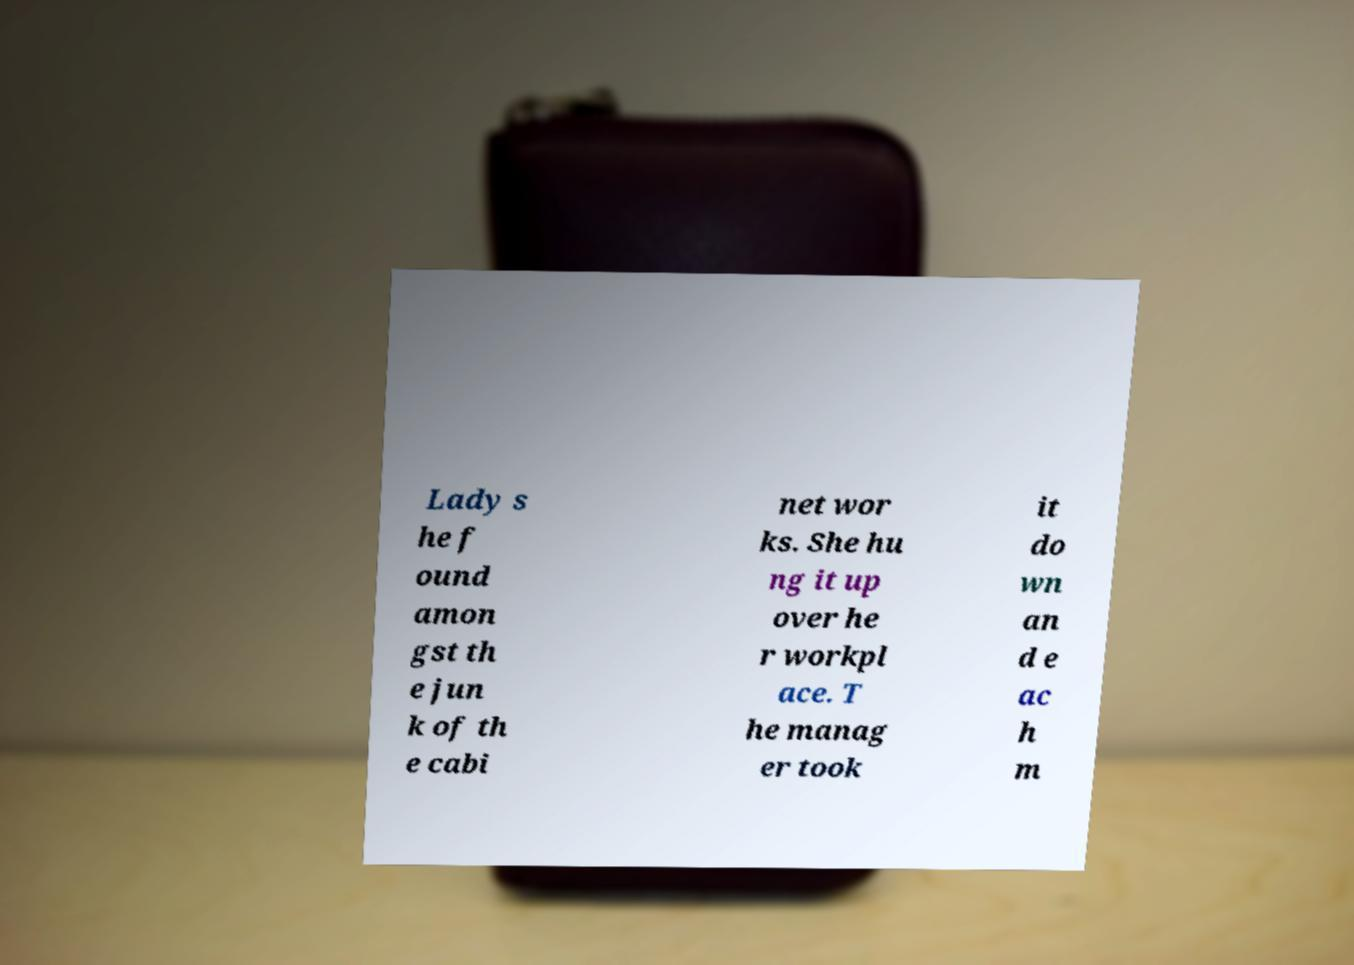Please identify and transcribe the text found in this image. Lady s he f ound amon gst th e jun k of th e cabi net wor ks. She hu ng it up over he r workpl ace. T he manag er took it do wn an d e ac h m 